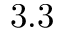<formula> <loc_0><loc_0><loc_500><loc_500>3 . 3</formula> 